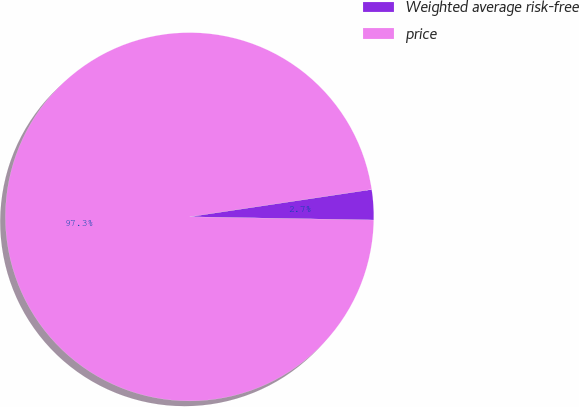Convert chart. <chart><loc_0><loc_0><loc_500><loc_500><pie_chart><fcel>Weighted average risk-free<fcel>price<nl><fcel>2.65%<fcel>97.35%<nl></chart> 